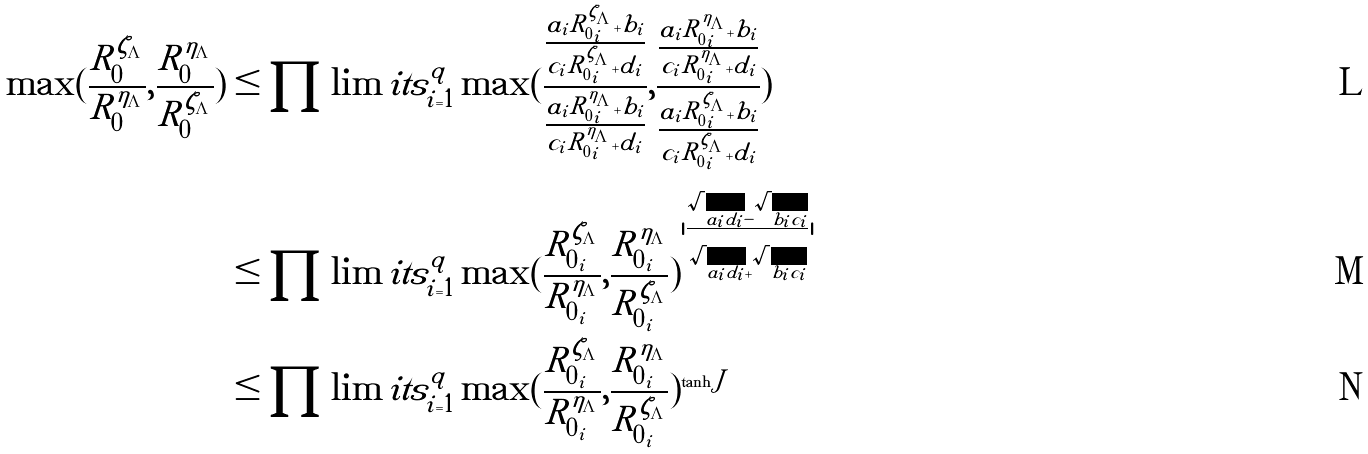<formula> <loc_0><loc_0><loc_500><loc_500>\max ( \frac { R ^ { \zeta _ { \Lambda } } _ { 0 } } { R ^ { \eta _ { \Lambda } } _ { 0 } } , \frac { R ^ { \eta _ { \Lambda } } _ { 0 } } { R ^ { \zeta _ { \Lambda } } _ { 0 } } ) & \leq \prod \lim i t s ^ { q } _ { i = 1 } \max ( \frac { \frac { a _ { i } R ^ { \zeta _ { \Lambda } } _ { 0 _ { i } } + b _ { i } } { c _ { i } R ^ { \zeta _ { \Lambda } } _ { 0 _ { i } } + d _ { i } } } { \frac { a _ { i } R ^ { \eta _ { \Lambda } } _ { 0 _ { i } } + b _ { i } } { c _ { i } R ^ { \eta _ { \Lambda } } _ { 0 _ { i } } + d _ { i } } } , \frac { \frac { a _ { i } R ^ { \eta _ { \Lambda } } _ { 0 _ { i } } + b _ { i } } { c _ { i } R ^ { \eta _ { \Lambda } } _ { 0 _ { i } } + d _ { i } } } { \frac { a _ { i } R ^ { \zeta _ { \Lambda } } _ { 0 _ { i } } + b _ { i } } { c _ { i } R ^ { \zeta _ { \Lambda } } _ { 0 _ { i } } + d _ { i } } } ) \\ & \leq \prod \lim i t s ^ { q } _ { i = 1 } \max ( \frac { R ^ { \zeta _ { \Lambda } } _ { 0 _ { i } } } { R ^ { \eta _ { \Lambda } } _ { 0 _ { i } } } , \frac { R ^ { \eta _ { \Lambda } } _ { 0 _ { i } } } { R ^ { \zeta _ { \Lambda } } _ { 0 _ { i } } } ) ^ { | \frac { \sqrt { a _ { i } d _ { i } } - \sqrt { b _ { i } c _ { i } } } { \sqrt { a _ { i } d _ { i } } + \sqrt { b _ { i } c _ { i } } } | } \\ & \leq \prod \lim i t s ^ { q } _ { i = 1 } \max ( \frac { R ^ { \zeta _ { \Lambda } } _ { 0 _ { i } } } { R ^ { \eta _ { \Lambda } } _ { 0 _ { i } } } , \frac { R ^ { \eta _ { \Lambda } } _ { 0 _ { i } } } { R ^ { \zeta _ { \Lambda } } _ { 0 _ { i } } } ) ^ { \tanh J }</formula> 